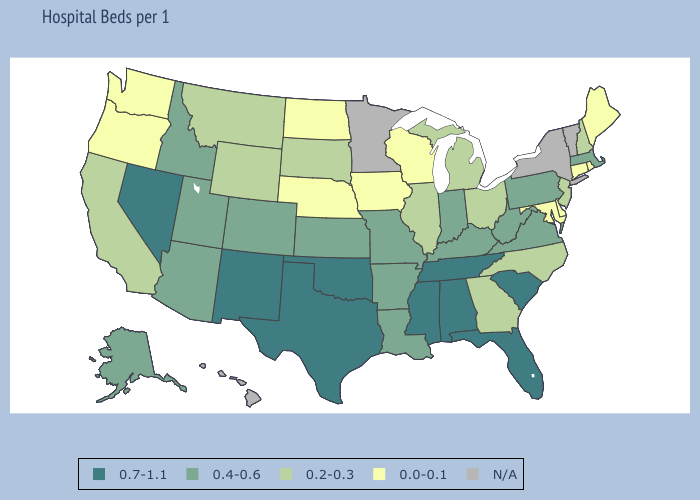Name the states that have a value in the range 0.4-0.6?
Quick response, please. Alaska, Arizona, Arkansas, Colorado, Idaho, Indiana, Kansas, Kentucky, Louisiana, Massachusetts, Missouri, Pennsylvania, Utah, Virginia, West Virginia. What is the value of Washington?
Give a very brief answer. 0.0-0.1. Does Delaware have the lowest value in the South?
Answer briefly. Yes. Name the states that have a value in the range 0.2-0.3?
Write a very short answer. California, Georgia, Illinois, Michigan, Montana, New Hampshire, New Jersey, North Carolina, Ohio, South Dakota, Wyoming. Name the states that have a value in the range 0.4-0.6?
Answer briefly. Alaska, Arizona, Arkansas, Colorado, Idaho, Indiana, Kansas, Kentucky, Louisiana, Massachusetts, Missouri, Pennsylvania, Utah, Virginia, West Virginia. Name the states that have a value in the range 0.2-0.3?
Give a very brief answer. California, Georgia, Illinois, Michigan, Montana, New Hampshire, New Jersey, North Carolina, Ohio, South Dakota, Wyoming. What is the value of Connecticut?
Give a very brief answer. 0.0-0.1. What is the lowest value in states that border Arizona?
Give a very brief answer. 0.2-0.3. Name the states that have a value in the range 0.4-0.6?
Short answer required. Alaska, Arizona, Arkansas, Colorado, Idaho, Indiana, Kansas, Kentucky, Louisiana, Massachusetts, Missouri, Pennsylvania, Utah, Virginia, West Virginia. Name the states that have a value in the range 0.2-0.3?
Answer briefly. California, Georgia, Illinois, Michigan, Montana, New Hampshire, New Jersey, North Carolina, Ohio, South Dakota, Wyoming. What is the lowest value in the MidWest?
Keep it brief. 0.0-0.1. What is the value of Maryland?
Quick response, please. 0.0-0.1. Which states have the lowest value in the USA?
Concise answer only. Connecticut, Delaware, Iowa, Maine, Maryland, Nebraska, North Dakota, Oregon, Rhode Island, Washington, Wisconsin. 